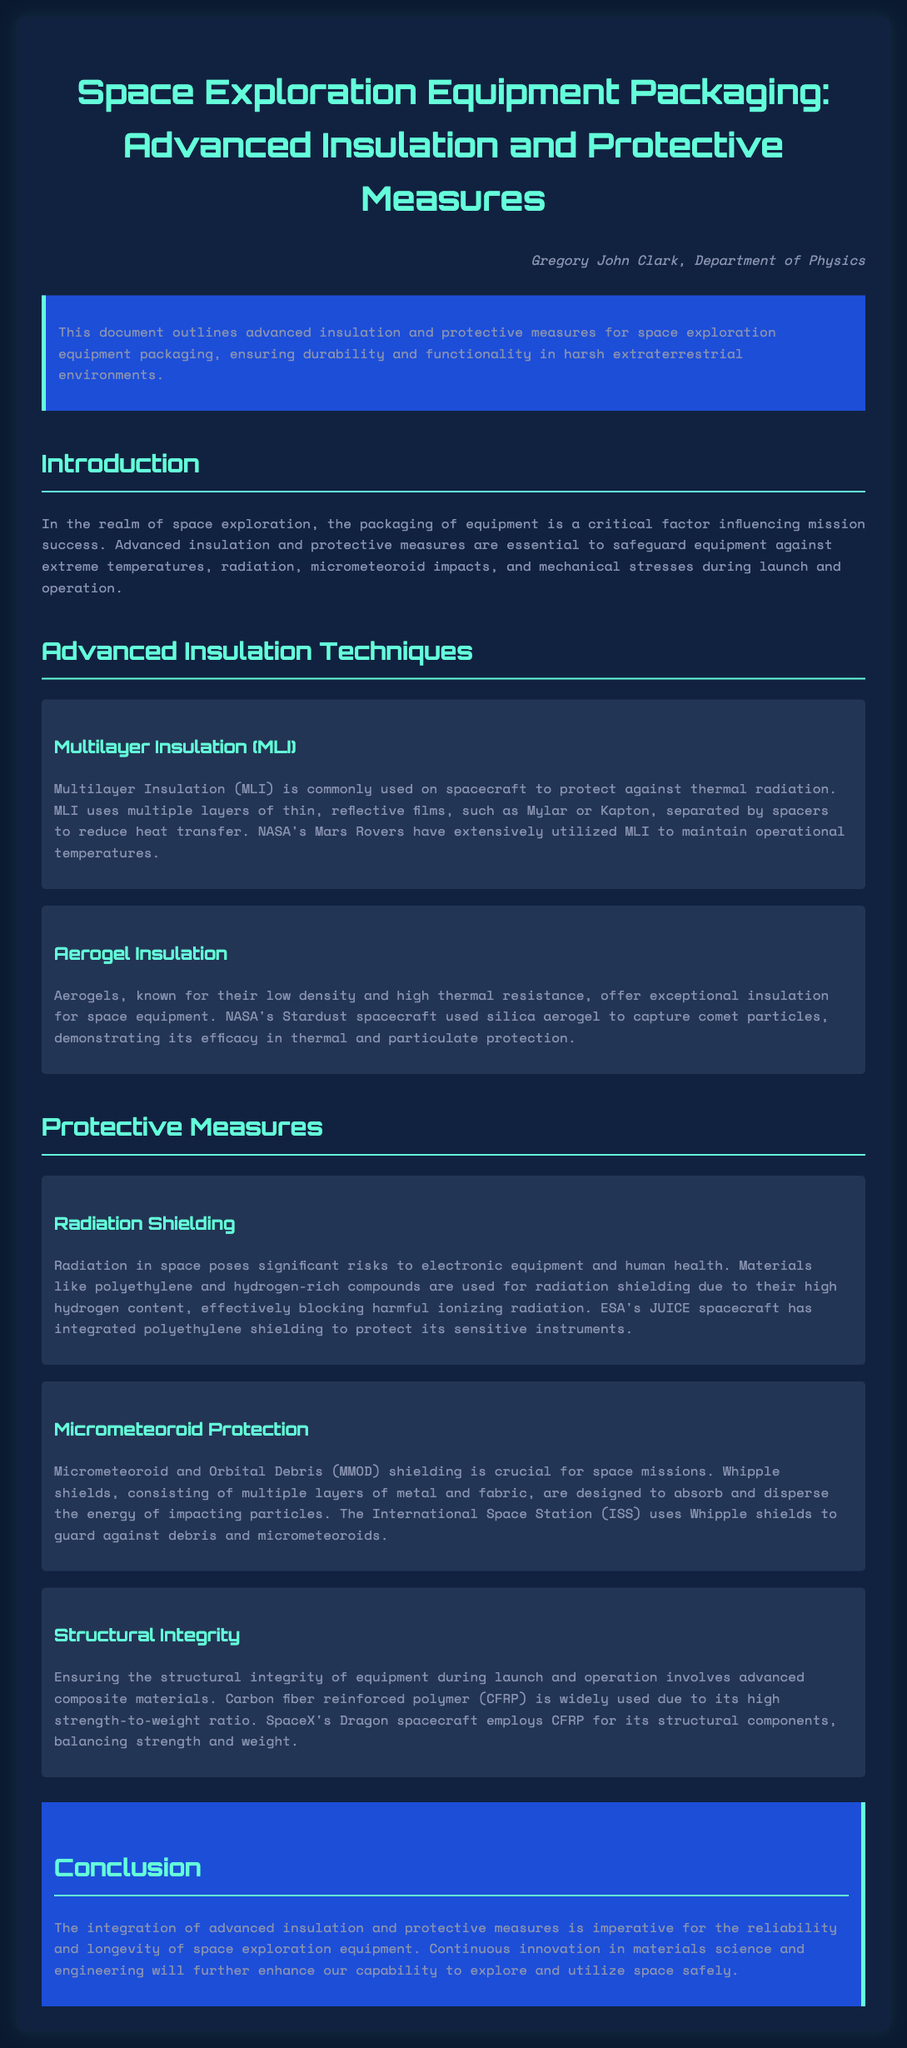What is the main focus of this document? The document outlines advanced insulation and protective measures for space exploration equipment packaging, ensuring durability and functionality in harsh extraterrestrial environments.
Answer: Advanced insulation and protective measures What does MLI stand for in space exploration? MLI is commonly used on spacecraft to protect against thermal radiation, and it stands for Multilayer Insulation.
Answer: Multilayer Insulation Which spacecraft used aerogel for insulation? The document mentions that NASA's Stardust spacecraft utilized silica aerogel for its thermal and particulate protection.
Answer: Stardust What materials are used for radiation shielding? The document lists materials like polyethylene and hydrogen-rich compounds used for radiation shielding due to their high hydrogen content.
Answer: Polyethylene and hydrogen-rich compounds What are Whipple shields designed to protect against? Whipple shields consist of multiple layers that absorb and disperse the energy of impacting particles, designed to protect against micrometeoroids and orbital debris.
Answer: Micrometeoroids and orbital debris Why is CFRP widely used in space equipment? CFRP is employed due to its high strength-to-weight ratio, which is critical for ensuring structural integrity during launch and operation.
Answer: High strength-to-weight ratio Which European spacecraft integrated polyethylene shielding? The document mentions that ESA's JUICE spacecraft has integrated polyethylene shielding to protect its sensitive instruments from harmful radiation.
Answer: JUICE What is a significant benefit of using advanced materials in space equipment? The integration of advanced materials enhances the reliability and longevity of space exploration equipment.
Answer: Reliability and longevity How does the document categorize advanced insulation techniques? The document categorizes advanced insulation techniques into sections, specifically discussing Multilayer Insulation and Aerogel Insulation.
Answer: Sections What does the conclusion emphasize about space equipment packaging? The conclusion emphasizes that continuous innovation in materials science and engineering will further enhance our capability to explore and utilize space safely.
Answer: Continuous innovation in materials science and engineering 